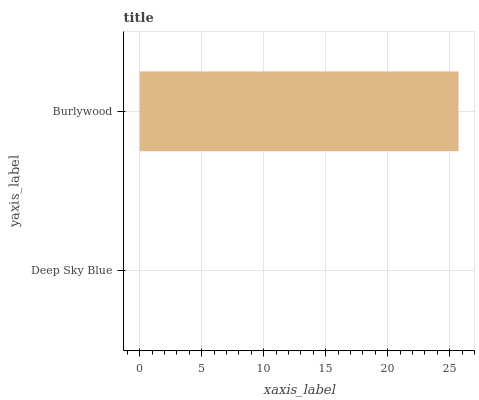Is Deep Sky Blue the minimum?
Answer yes or no. Yes. Is Burlywood the maximum?
Answer yes or no. Yes. Is Burlywood the minimum?
Answer yes or no. No. Is Burlywood greater than Deep Sky Blue?
Answer yes or no. Yes. Is Deep Sky Blue less than Burlywood?
Answer yes or no. Yes. Is Deep Sky Blue greater than Burlywood?
Answer yes or no. No. Is Burlywood less than Deep Sky Blue?
Answer yes or no. No. Is Burlywood the high median?
Answer yes or no. Yes. Is Deep Sky Blue the low median?
Answer yes or no. Yes. Is Deep Sky Blue the high median?
Answer yes or no. No. Is Burlywood the low median?
Answer yes or no. No. 